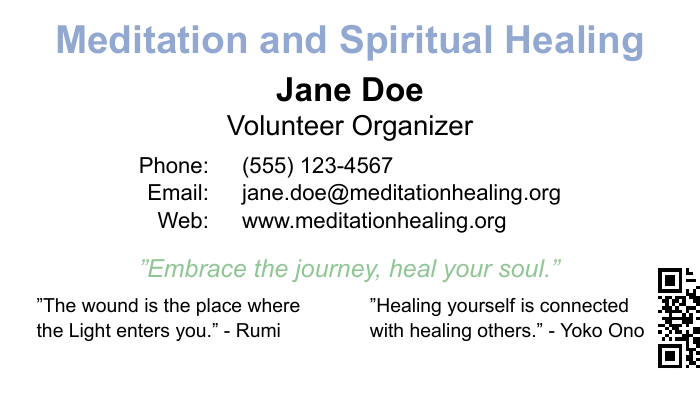What is the name of the volunteer organizer? The volunteer organizer's name is explicitly stated at the top of the document.
Answer: Jane Doe What is the contact phone number? The document provides the contact phone number in a clear format.
Answer: (555) 123-4567 What is the email address listed on the card? The email address is shown under the contact information section of the document.
Answer: jane.doe@meditationhealing.org What is the quote about healing from Yoko Ono? This quote is listed in a prominent position on the card, focused on healing.
Answer: "Healing yourself is connected with healing others." What color is used for the main title? The title color can be determined by observing the text formatting in the document.
Answer: Serenity blue What organization is the card associated with? The name of the organization can be inferred from the web address included on the card.
Answer: meditation healing What does the card suggest about the journey? The card features a specific quote that reflects on the journey of healing.
Answer: "Embrace the journey, heal your soul." What imagery style is suggested by the card's content? The use of words in the quotes and the color scheme hints at a peaceful, calming style reflected in nature.
Answer: Serene nature imagery How can you access more information about the organization? The card includes a QR code that can be scanned for more details.
Answer: By scanning the QR code 